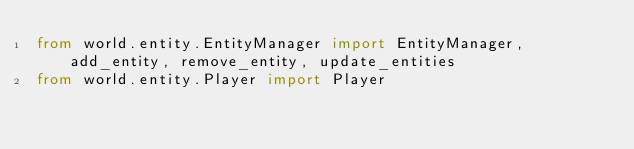<code> <loc_0><loc_0><loc_500><loc_500><_Python_>from world.entity.EntityManager import EntityManager, add_entity, remove_entity, update_entities
from world.entity.Player import Player
</code> 